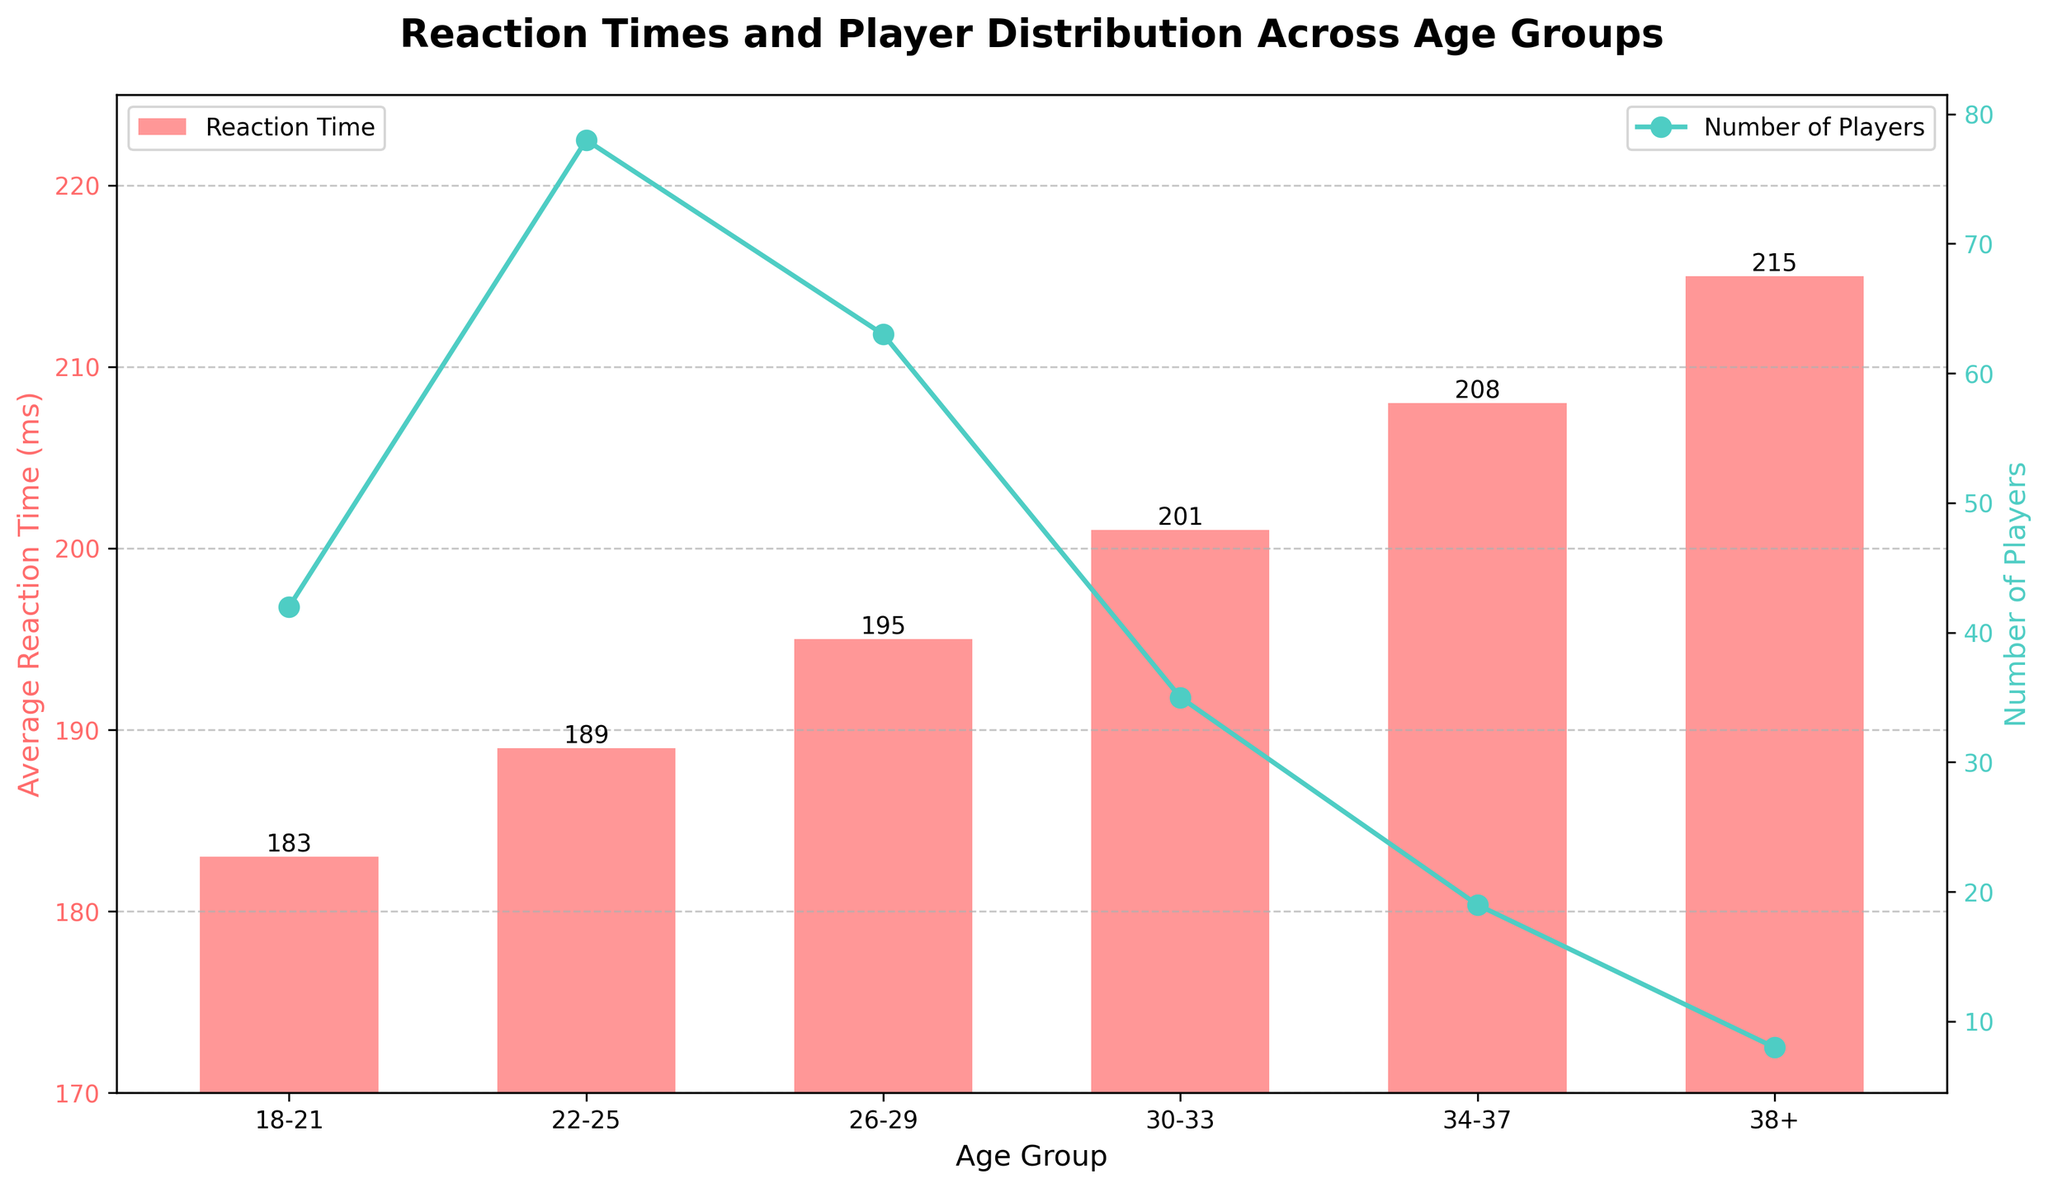Which age group has the lowest average reaction time? The bar chart shows different average reaction times, with the shortest bar indicating the lowest reaction time. The 18-21 age group has the shortest bar.
Answer: 18-21 How many players are there in the 26-29 age group? The line plot with markers on the secondary y-axis represents the number of players. By referring to the marker above the 26-29 age group, we see the value is 63.
Answer: 63 Which age group has the highest number of players? The line plot has the peak value representing the highest number of players. The 22-25 age group has the highest value.
Answer: 22-25 By how many milliseconds does the average reaction time of the 34-37 age group exceed that of the 18-21 age group? The average reaction times for the 34-37 and 18-21 age groups are 208 ms and 183 ms, respectively. The difference is 208 - 183 = 25 ms.
Answer: 25 ms What is the overall trend in average reaction time as age increases? The bars representing average reaction times increase in height from left to right, indicating that reaction time increases with age.
Answer: Increases Is the average reaction time of the 26-29 age group closer to that of the 22-25 or the 30-33 age group? The average reaction times are 189 ms for 22-25, 195 ms for 26-29, and 201 ms for 30-33. The difference between 195 and 189 is 6, and between 195 and 201 is also 6 ms. Thus, the reaction times are equally close to both groups.
Answer: Equally close How does the number of players in the 30-33 age group compare to the 38+ age group? The number of players in the 30-33 age group is 35, while the number for the 38+ age group is 8. 35 is greater than 8.
Answer: More What is the difference in average reaction times between the oldest and youngest age groups? The reaction times are 215 ms for the 38+ age group and 183 ms for the 18-21 age group. The difference is 215 - 183 = 32 ms.
Answer: 32 ms 